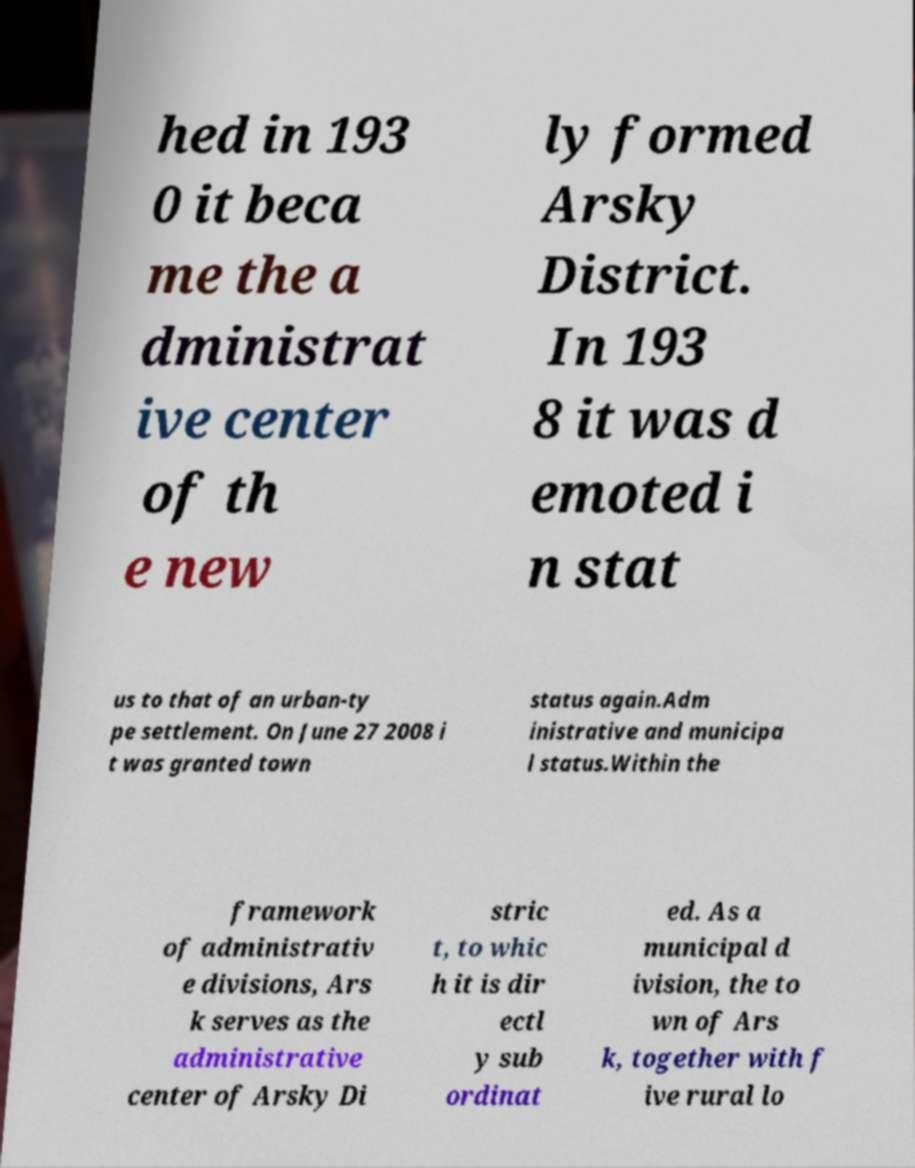What messages or text are displayed in this image? I need them in a readable, typed format. hed in 193 0 it beca me the a dministrat ive center of th e new ly formed Arsky District. In 193 8 it was d emoted i n stat us to that of an urban-ty pe settlement. On June 27 2008 i t was granted town status again.Adm inistrative and municipa l status.Within the framework of administrativ e divisions, Ars k serves as the administrative center of Arsky Di stric t, to whic h it is dir ectl y sub ordinat ed. As a municipal d ivision, the to wn of Ars k, together with f ive rural lo 